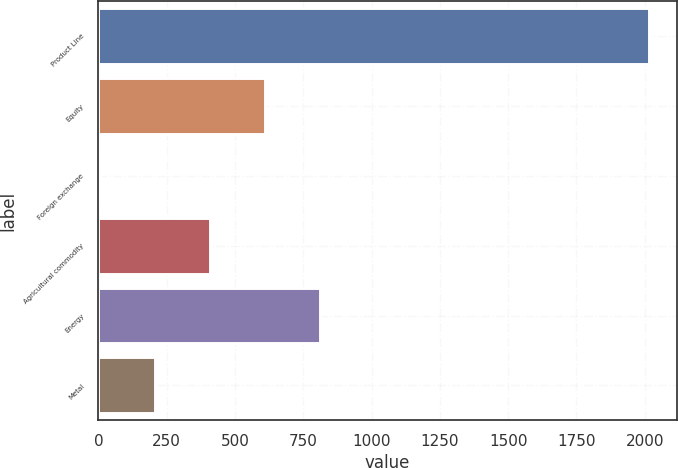Convert chart. <chart><loc_0><loc_0><loc_500><loc_500><bar_chart><fcel>Product Line<fcel>Equity<fcel>Foreign exchange<fcel>Agricultural commodity<fcel>Energy<fcel>Metal<nl><fcel>2016<fcel>609<fcel>6<fcel>408<fcel>810<fcel>207<nl></chart> 